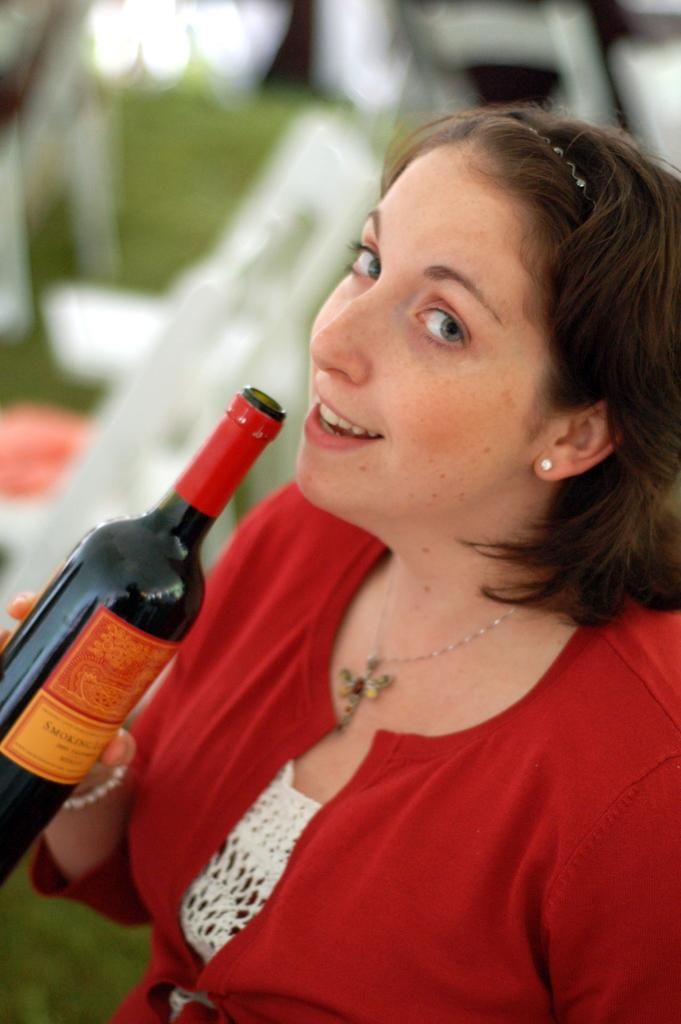What is the main subject of the image? There is a woman in the image. What is the woman holding in her hand? The woman is holding a bottle in her hand. What type of hammer is the woman using in the image? There is no hammer present in the image; the woman is holding a bottle. What does the woman's expression convey in the image? The provided facts do not mention the woman's expression, so we cannot determine her emotions or feelings from the image. 